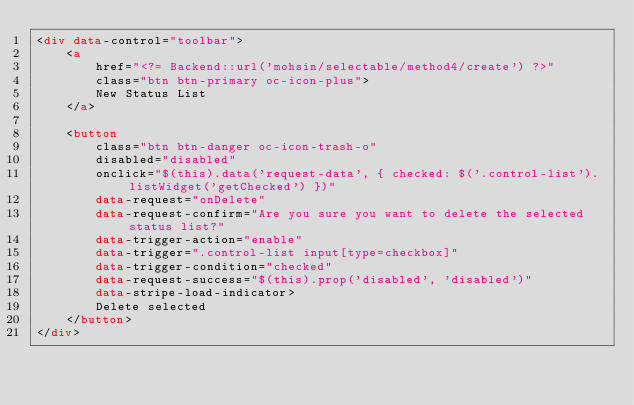<code> <loc_0><loc_0><loc_500><loc_500><_HTML_><div data-control="toolbar">
    <a
        href="<?= Backend::url('mohsin/selectable/method4/create') ?>"
        class="btn btn-primary oc-icon-plus">
        New Status List
    </a>

    <button
        class="btn btn-danger oc-icon-trash-o"
        disabled="disabled"
        onclick="$(this).data('request-data', { checked: $('.control-list').listWidget('getChecked') })"
        data-request="onDelete"
        data-request-confirm="Are you sure you want to delete the selected status list?"
        data-trigger-action="enable"
        data-trigger=".control-list input[type=checkbox]"
        data-trigger-condition="checked"
        data-request-success="$(this).prop('disabled', 'disabled')"
        data-stripe-load-indicator>
        Delete selected
    </button>
</div>
</code> 